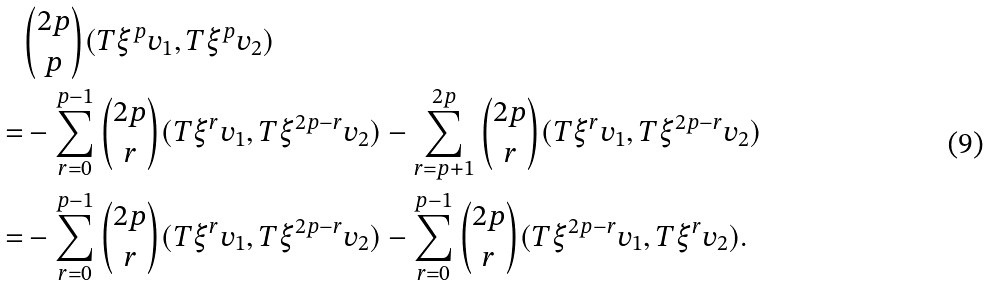<formula> <loc_0><loc_0><loc_500><loc_500>& \binom { 2 p } { p } ( T \xi ^ { p } v _ { 1 } , T \xi ^ { p } v _ { 2 } ) \\ = & - \sum _ { r = 0 } ^ { p - 1 } \binom { 2 p } { r } ( T \xi ^ { r } v _ { 1 } , T \xi ^ { 2 p - r } v _ { 2 } ) - \sum _ { r = p + 1 } ^ { 2 p } \binom { 2 p } { r } ( T \xi ^ { r } v _ { 1 } , T \xi ^ { 2 p - r } v _ { 2 } ) \\ = & - \sum _ { r = 0 } ^ { p - 1 } \binom { 2 p } { r } ( T \xi ^ { r } v _ { 1 } , T \xi ^ { 2 p - r } v _ { 2 } ) - \sum _ { r = 0 } ^ { p - 1 } \binom { 2 p } { r } ( T \xi ^ { 2 p - r } v _ { 1 } , T \xi ^ { r } v _ { 2 } ) .</formula> 